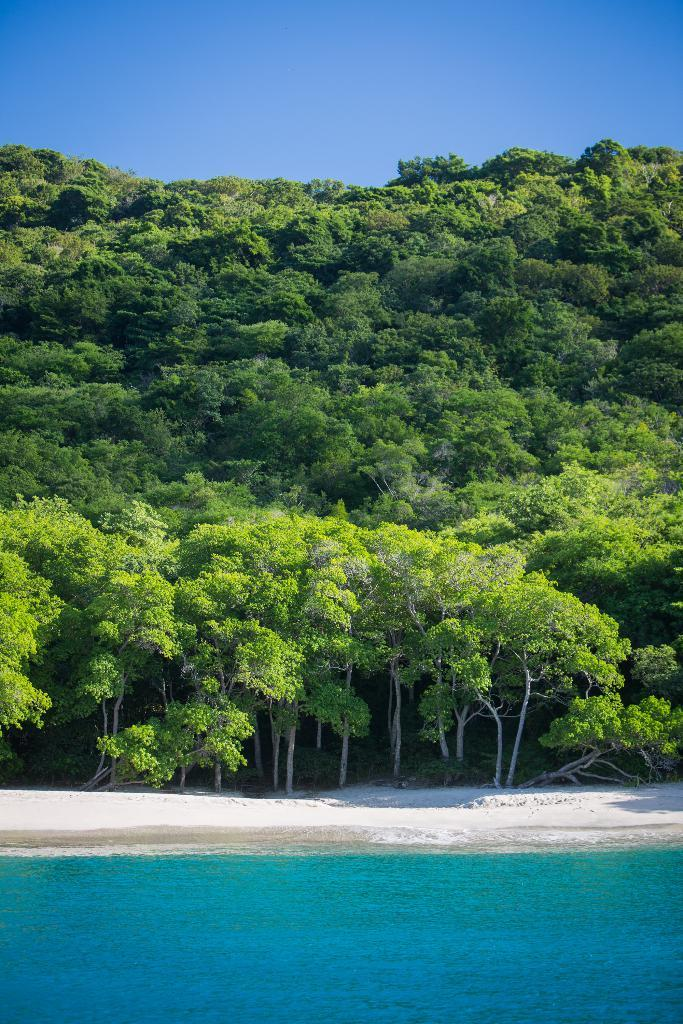What type of landform is present in the image? There is a hill in the image. What type of vegetation can be seen in the image? There are trees in the image. What type of terrain is present in the image? There is sand in the image. What type of body of water is present in the image? There is water in the image. What can be seen in the background of the image? The sky is visible in the background of the image. What type of quilt is being used to cover the water in the image? There is no quilt present in the image; it is a natural scene with water and other elements. 